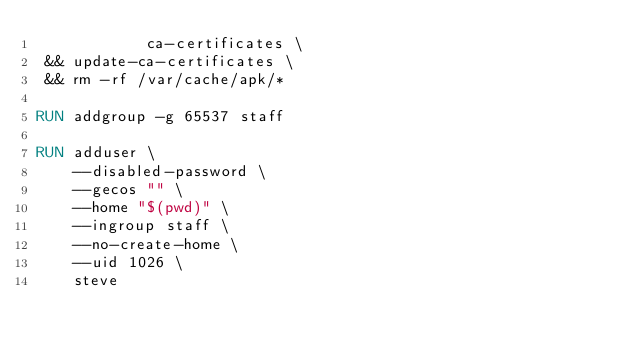Convert code to text. <code><loc_0><loc_0><loc_500><loc_500><_Dockerfile_>            ca-certificates \
 && update-ca-certificates \
 && rm -rf /var/cache/apk/*

RUN addgroup -g 65537 staff

RUN adduser \
    --disabled-password \
    --gecos "" \
    --home "$(pwd)" \
    --ingroup staff \
    --no-create-home \
    --uid 1026 \
    steve
</code> 